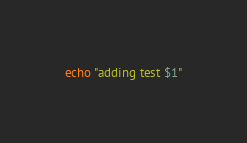Convert code to text. <code><loc_0><loc_0><loc_500><loc_500><_Bash_>echo "adding test $1"
</code> 